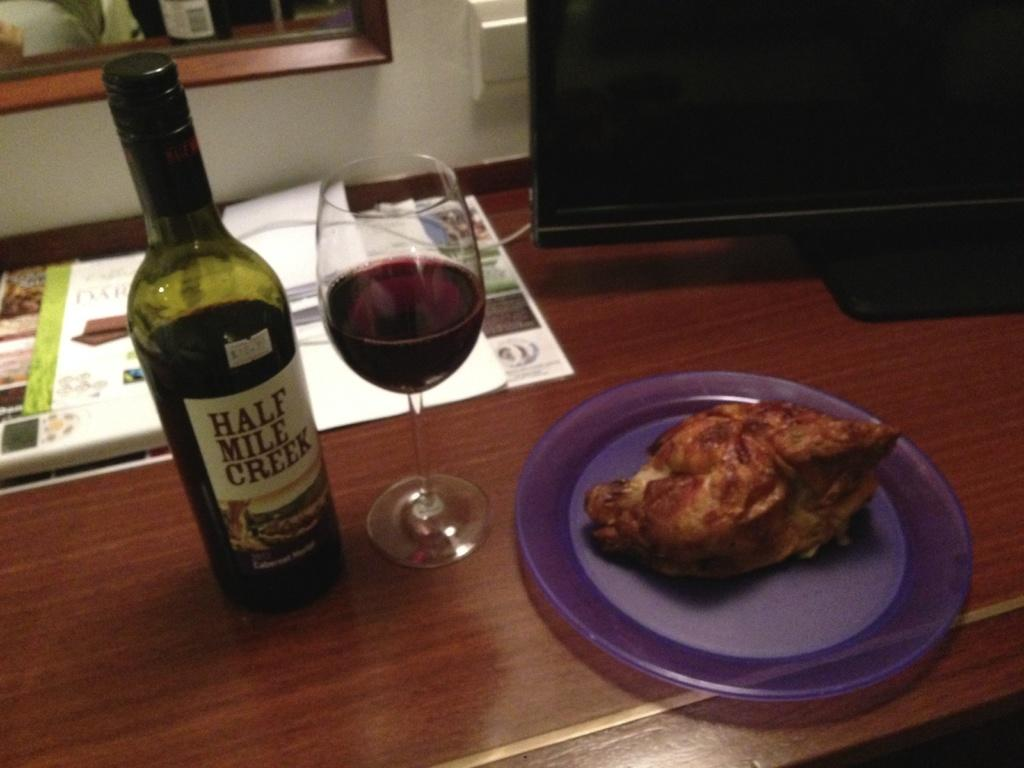What piece of furniture is present in the image? There is a table in the image. What is placed on the table? There is a plate, a meat piece, a wine glass, a wine bottle, books, and a monitor on the table. What type of food is on the plate? There is a meat piece on the plate. What type of beverage is associated with the wine glass and bottle? Wine is associated with the wine glass and bottle. How many slaves are visible in the image? There are no slaves present in the image. What type of fish can be seen swimming in the wine glass? There are no fish present in the image, and the wine glass is not filled with water. 